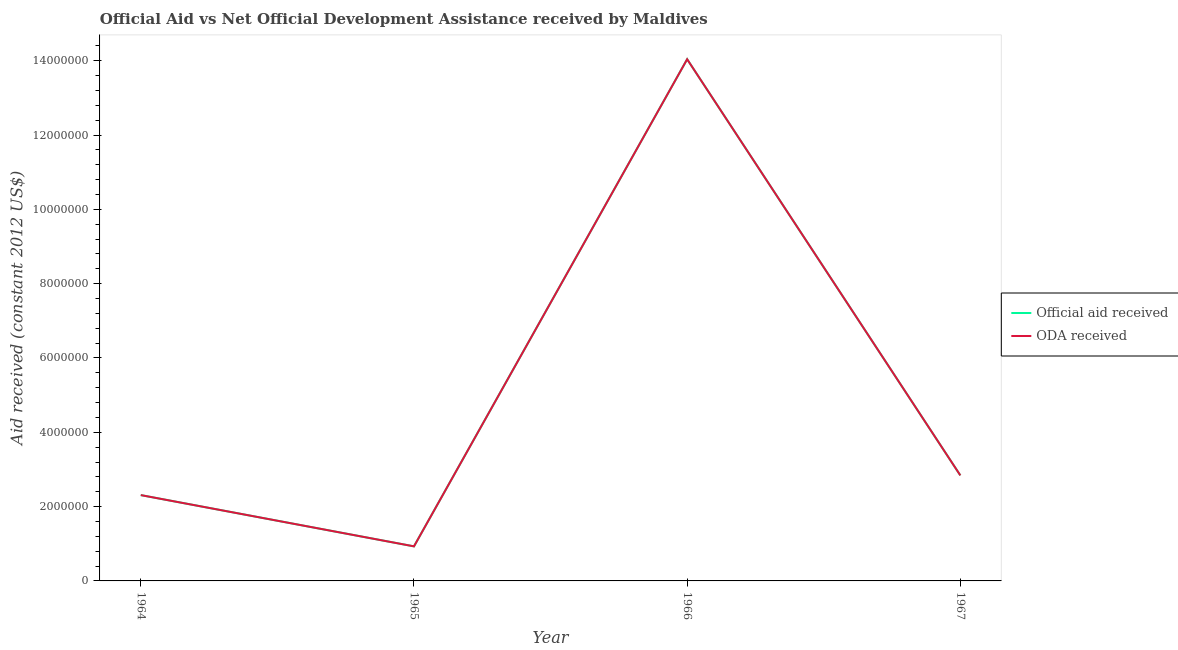Does the line corresponding to oda received intersect with the line corresponding to official aid received?
Your answer should be compact. Yes. Is the number of lines equal to the number of legend labels?
Your answer should be very brief. Yes. What is the official aid received in 1964?
Keep it short and to the point. 2.31e+06. Across all years, what is the maximum official aid received?
Give a very brief answer. 1.40e+07. Across all years, what is the minimum official aid received?
Your answer should be very brief. 9.30e+05. In which year was the oda received maximum?
Your answer should be compact. 1966. In which year was the official aid received minimum?
Provide a short and direct response. 1965. What is the total official aid received in the graph?
Ensure brevity in your answer.  2.01e+07. What is the difference between the oda received in 1964 and that in 1966?
Your response must be concise. -1.17e+07. What is the difference between the oda received in 1966 and the official aid received in 1965?
Your response must be concise. 1.31e+07. What is the average official aid received per year?
Offer a terse response. 5.03e+06. In the year 1964, what is the difference between the official aid received and oda received?
Your answer should be compact. 0. What is the ratio of the official aid received in 1965 to that in 1967?
Offer a terse response. 0.33. Is the official aid received in 1964 less than that in 1967?
Offer a terse response. Yes. What is the difference between the highest and the second highest official aid received?
Your answer should be very brief. 1.12e+07. What is the difference between the highest and the lowest oda received?
Your answer should be compact. 1.31e+07. In how many years, is the official aid received greater than the average official aid received taken over all years?
Provide a succinct answer. 1. Does the oda received monotonically increase over the years?
Provide a short and direct response. No. Is the oda received strictly greater than the official aid received over the years?
Keep it short and to the point. No. How many lines are there?
Offer a very short reply. 2. How many years are there in the graph?
Your answer should be compact. 4. Are the values on the major ticks of Y-axis written in scientific E-notation?
Provide a succinct answer. No. Does the graph contain any zero values?
Provide a short and direct response. No. Does the graph contain grids?
Provide a succinct answer. No. How many legend labels are there?
Keep it short and to the point. 2. How are the legend labels stacked?
Make the answer very short. Vertical. What is the title of the graph?
Keep it short and to the point. Official Aid vs Net Official Development Assistance received by Maldives . Does "Techinal cooperation" appear as one of the legend labels in the graph?
Keep it short and to the point. No. What is the label or title of the Y-axis?
Your response must be concise. Aid received (constant 2012 US$). What is the Aid received (constant 2012 US$) of Official aid received in 1964?
Your answer should be compact. 2.31e+06. What is the Aid received (constant 2012 US$) in ODA received in 1964?
Ensure brevity in your answer.  2.31e+06. What is the Aid received (constant 2012 US$) in Official aid received in 1965?
Your answer should be compact. 9.30e+05. What is the Aid received (constant 2012 US$) of ODA received in 1965?
Keep it short and to the point. 9.30e+05. What is the Aid received (constant 2012 US$) in Official aid received in 1966?
Make the answer very short. 1.40e+07. What is the Aid received (constant 2012 US$) of ODA received in 1966?
Ensure brevity in your answer.  1.40e+07. What is the Aid received (constant 2012 US$) of Official aid received in 1967?
Your answer should be very brief. 2.84e+06. What is the Aid received (constant 2012 US$) in ODA received in 1967?
Offer a terse response. 2.84e+06. Across all years, what is the maximum Aid received (constant 2012 US$) in Official aid received?
Offer a very short reply. 1.40e+07. Across all years, what is the maximum Aid received (constant 2012 US$) in ODA received?
Your answer should be very brief. 1.40e+07. Across all years, what is the minimum Aid received (constant 2012 US$) of Official aid received?
Offer a very short reply. 9.30e+05. Across all years, what is the minimum Aid received (constant 2012 US$) of ODA received?
Provide a short and direct response. 9.30e+05. What is the total Aid received (constant 2012 US$) of Official aid received in the graph?
Provide a short and direct response. 2.01e+07. What is the total Aid received (constant 2012 US$) of ODA received in the graph?
Ensure brevity in your answer.  2.01e+07. What is the difference between the Aid received (constant 2012 US$) in Official aid received in 1964 and that in 1965?
Your answer should be compact. 1.38e+06. What is the difference between the Aid received (constant 2012 US$) in ODA received in 1964 and that in 1965?
Your answer should be compact. 1.38e+06. What is the difference between the Aid received (constant 2012 US$) of Official aid received in 1964 and that in 1966?
Provide a succinct answer. -1.17e+07. What is the difference between the Aid received (constant 2012 US$) of ODA received in 1964 and that in 1966?
Your answer should be compact. -1.17e+07. What is the difference between the Aid received (constant 2012 US$) in Official aid received in 1964 and that in 1967?
Offer a terse response. -5.30e+05. What is the difference between the Aid received (constant 2012 US$) in ODA received in 1964 and that in 1967?
Provide a short and direct response. -5.30e+05. What is the difference between the Aid received (constant 2012 US$) of Official aid received in 1965 and that in 1966?
Provide a succinct answer. -1.31e+07. What is the difference between the Aid received (constant 2012 US$) in ODA received in 1965 and that in 1966?
Give a very brief answer. -1.31e+07. What is the difference between the Aid received (constant 2012 US$) of Official aid received in 1965 and that in 1967?
Make the answer very short. -1.91e+06. What is the difference between the Aid received (constant 2012 US$) of ODA received in 1965 and that in 1967?
Your answer should be compact. -1.91e+06. What is the difference between the Aid received (constant 2012 US$) in Official aid received in 1966 and that in 1967?
Your answer should be compact. 1.12e+07. What is the difference between the Aid received (constant 2012 US$) of ODA received in 1966 and that in 1967?
Your answer should be compact. 1.12e+07. What is the difference between the Aid received (constant 2012 US$) of Official aid received in 1964 and the Aid received (constant 2012 US$) of ODA received in 1965?
Offer a very short reply. 1.38e+06. What is the difference between the Aid received (constant 2012 US$) of Official aid received in 1964 and the Aid received (constant 2012 US$) of ODA received in 1966?
Offer a very short reply. -1.17e+07. What is the difference between the Aid received (constant 2012 US$) in Official aid received in 1964 and the Aid received (constant 2012 US$) in ODA received in 1967?
Ensure brevity in your answer.  -5.30e+05. What is the difference between the Aid received (constant 2012 US$) of Official aid received in 1965 and the Aid received (constant 2012 US$) of ODA received in 1966?
Provide a short and direct response. -1.31e+07. What is the difference between the Aid received (constant 2012 US$) of Official aid received in 1965 and the Aid received (constant 2012 US$) of ODA received in 1967?
Offer a terse response. -1.91e+06. What is the difference between the Aid received (constant 2012 US$) in Official aid received in 1966 and the Aid received (constant 2012 US$) in ODA received in 1967?
Provide a succinct answer. 1.12e+07. What is the average Aid received (constant 2012 US$) of Official aid received per year?
Provide a short and direct response. 5.03e+06. What is the average Aid received (constant 2012 US$) in ODA received per year?
Your answer should be very brief. 5.03e+06. In the year 1965, what is the difference between the Aid received (constant 2012 US$) of Official aid received and Aid received (constant 2012 US$) of ODA received?
Your answer should be compact. 0. In the year 1966, what is the difference between the Aid received (constant 2012 US$) in Official aid received and Aid received (constant 2012 US$) in ODA received?
Make the answer very short. 0. What is the ratio of the Aid received (constant 2012 US$) of Official aid received in 1964 to that in 1965?
Your response must be concise. 2.48. What is the ratio of the Aid received (constant 2012 US$) in ODA received in 1964 to that in 1965?
Provide a succinct answer. 2.48. What is the ratio of the Aid received (constant 2012 US$) of Official aid received in 1964 to that in 1966?
Make the answer very short. 0.16. What is the ratio of the Aid received (constant 2012 US$) of ODA received in 1964 to that in 1966?
Give a very brief answer. 0.16. What is the ratio of the Aid received (constant 2012 US$) in Official aid received in 1964 to that in 1967?
Keep it short and to the point. 0.81. What is the ratio of the Aid received (constant 2012 US$) in ODA received in 1964 to that in 1967?
Give a very brief answer. 0.81. What is the ratio of the Aid received (constant 2012 US$) of Official aid received in 1965 to that in 1966?
Provide a short and direct response. 0.07. What is the ratio of the Aid received (constant 2012 US$) in ODA received in 1965 to that in 1966?
Keep it short and to the point. 0.07. What is the ratio of the Aid received (constant 2012 US$) of Official aid received in 1965 to that in 1967?
Your answer should be very brief. 0.33. What is the ratio of the Aid received (constant 2012 US$) in ODA received in 1965 to that in 1967?
Give a very brief answer. 0.33. What is the ratio of the Aid received (constant 2012 US$) in Official aid received in 1966 to that in 1967?
Your answer should be compact. 4.94. What is the ratio of the Aid received (constant 2012 US$) in ODA received in 1966 to that in 1967?
Your answer should be compact. 4.94. What is the difference between the highest and the second highest Aid received (constant 2012 US$) in Official aid received?
Give a very brief answer. 1.12e+07. What is the difference between the highest and the second highest Aid received (constant 2012 US$) in ODA received?
Your response must be concise. 1.12e+07. What is the difference between the highest and the lowest Aid received (constant 2012 US$) of Official aid received?
Offer a very short reply. 1.31e+07. What is the difference between the highest and the lowest Aid received (constant 2012 US$) of ODA received?
Provide a short and direct response. 1.31e+07. 